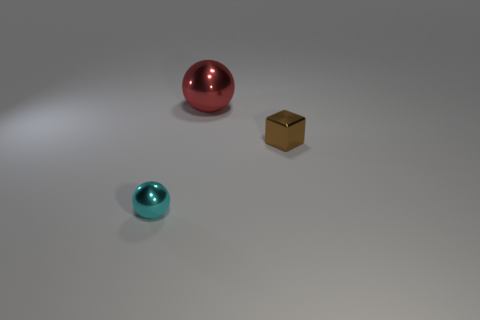Are there any other things that have the same size as the red metallic sphere?
Provide a short and direct response. No. There is a sphere that is behind the tiny brown metal object; what is it made of?
Your answer should be compact. Metal. Does the shiny block have the same size as the cyan object?
Give a very brief answer. Yes. What is the color of the shiny object that is both behind the small cyan shiny thing and to the left of the brown metallic cube?
Make the answer very short. Red. There is a small brown thing that is the same material as the big red ball; what shape is it?
Ensure brevity in your answer.  Cube. How many objects are on the left side of the large red metallic ball and to the right of the large red shiny thing?
Provide a short and direct response. 0. There is a cyan shiny ball; are there any tiny blocks left of it?
Offer a terse response. No. Do the small metal object to the left of the small brown metallic cube and the small object that is right of the tiny metallic sphere have the same shape?
Your answer should be very brief. No. How many objects are either large metal spheres or spheres that are in front of the brown cube?
Keep it short and to the point. 2. What number of other objects are there of the same shape as the small brown metallic thing?
Provide a short and direct response. 0. 